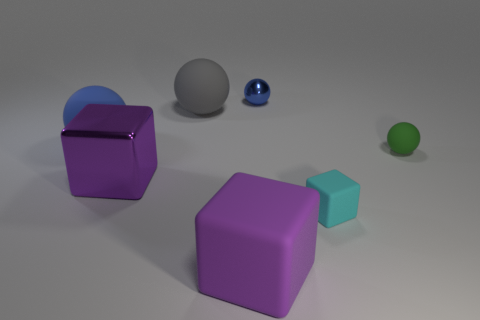Are there the same number of cyan rubber things that are on the left side of the blue matte ball and tiny green metallic cubes? Yes, there are the same number of cyan rubber objects as there are tiny green metallic cubes located to the left of the blue matte ball — each group contains a single item. 